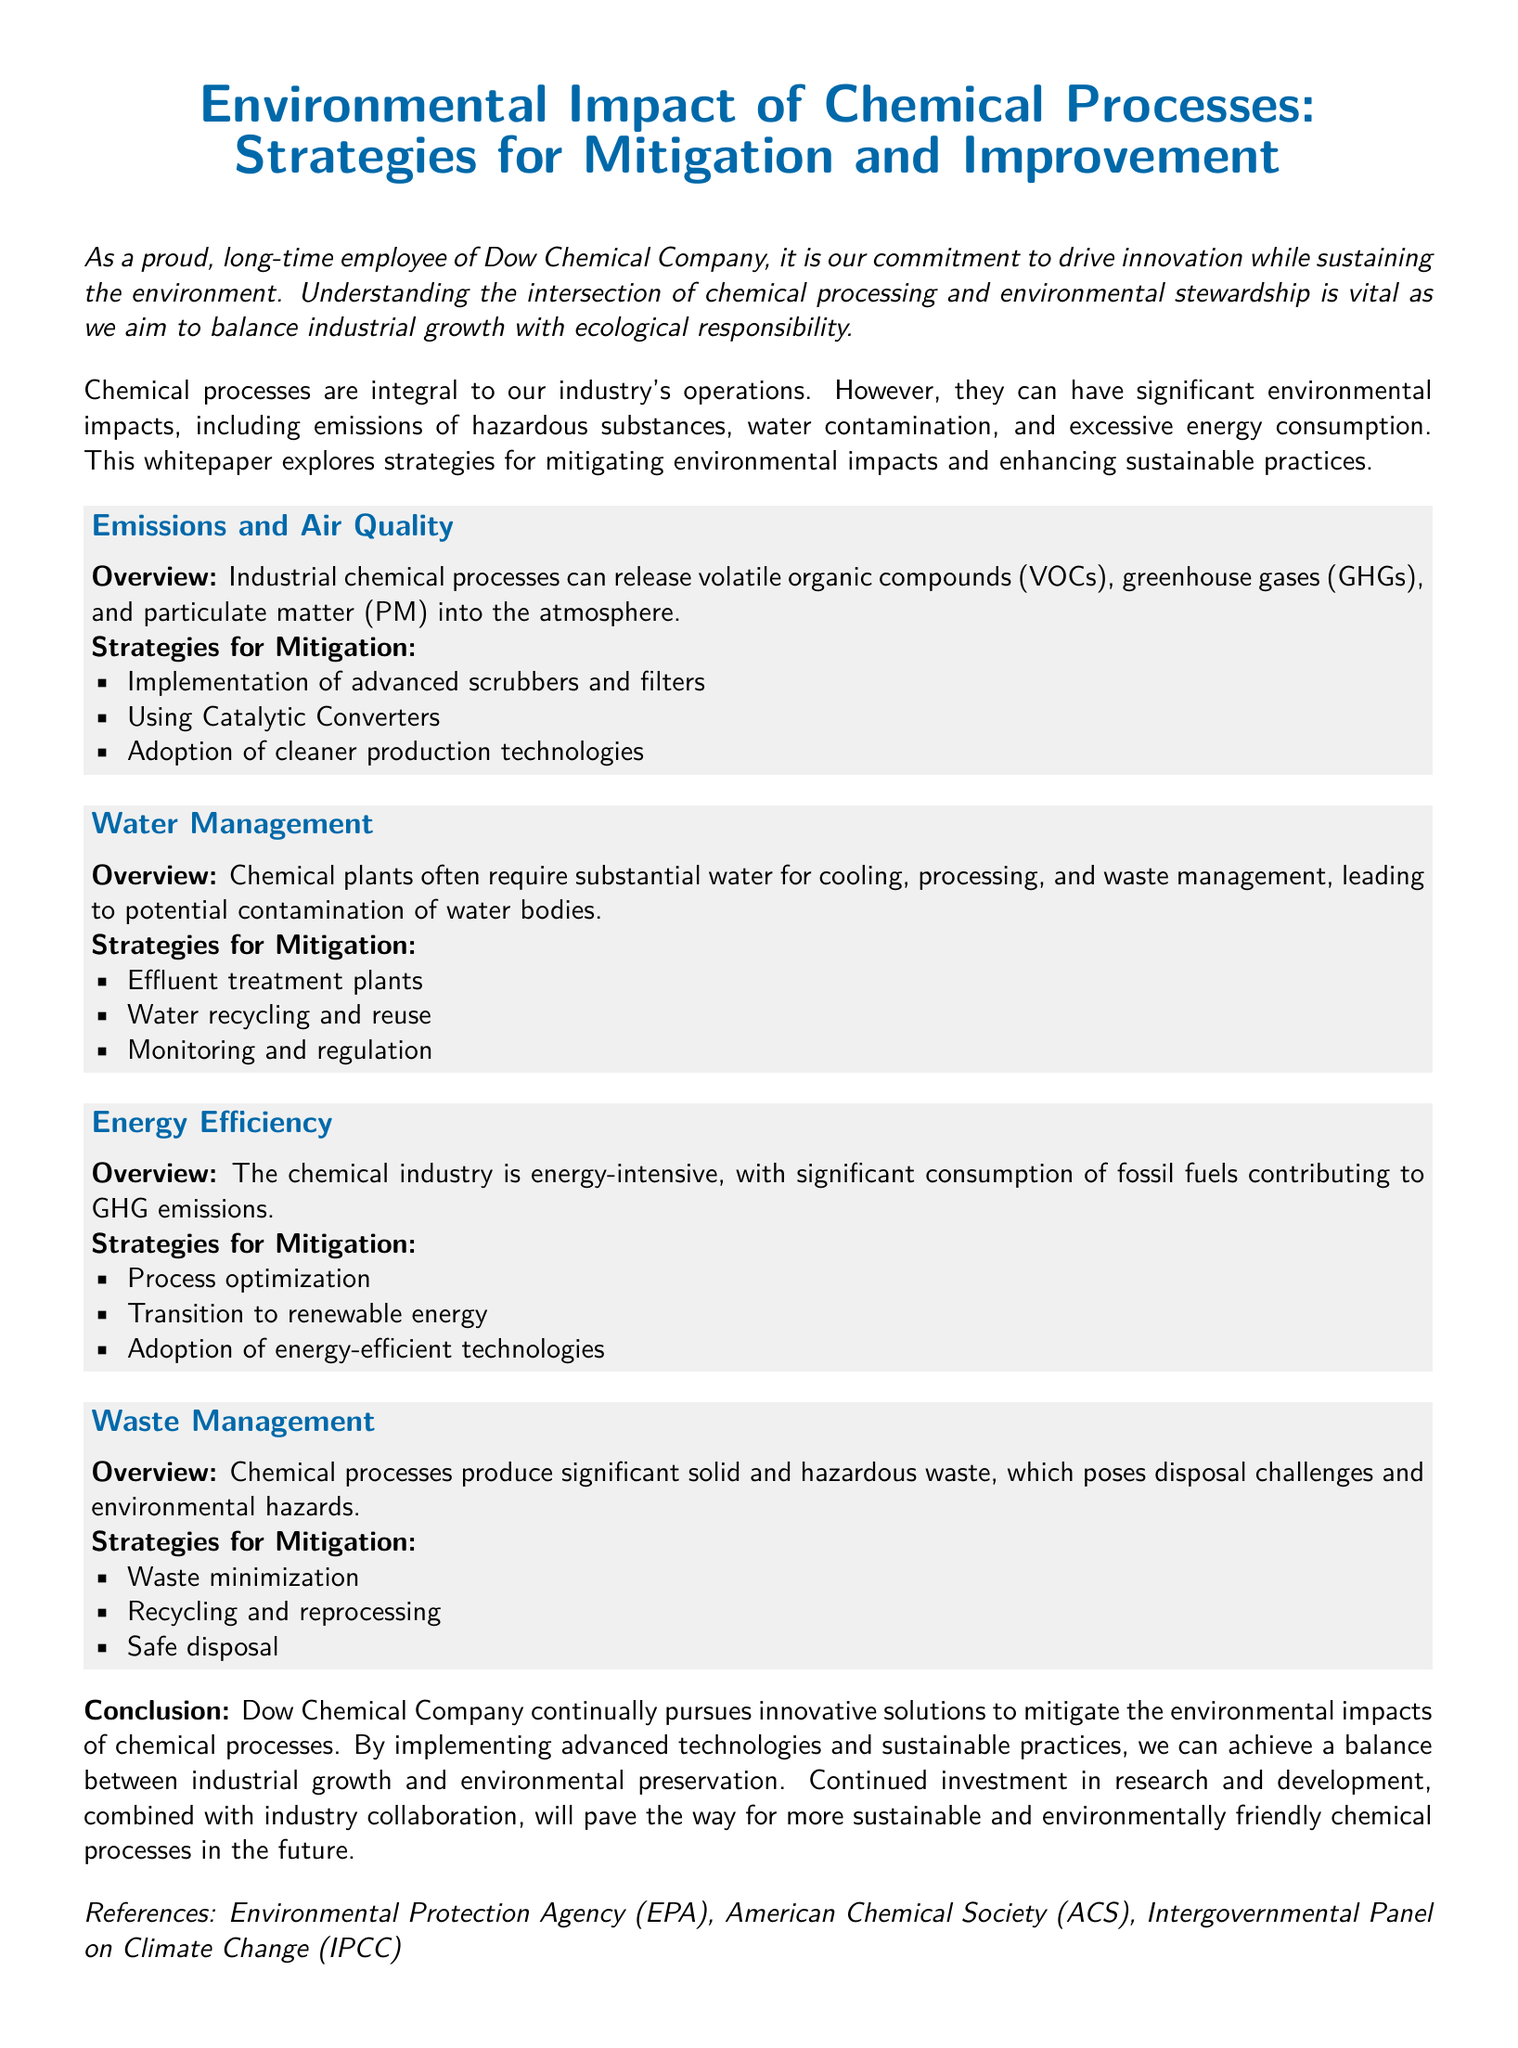What is the main commitment of Dow Chemical Company mentioned in the document? The document states that Dow Chemical Company is committed to driving innovation while sustaining the environment.
Answer: driving innovation while sustaining the environment What are the three types of emissions from chemical processes listed? The document lists volatile organic compounds, greenhouse gases, and particulate matter as emissions from chemical processes.
Answer: volatile organic compounds, greenhouse gases, particulate matter What is one strategy for mitigating emissions? The document lists the implementation of advanced scrubbers and filters as a strategy for mitigating emissions.
Answer: implementation of advanced scrubbers and filters What do chemical plants often require substantial amounts of? The document mentions that chemical plants often require substantial amounts of water for cooling, processing, and waste management.
Answer: water What is a strategy for water management mentioned in the document? One strategy for water management mentioned is water recycling and reuse.
Answer: water recycling and reuse What type of waste poses disposal challenges according to the document? The document states that significant solid and hazardous waste produced by chemical processes poses disposal challenges.
Answer: significant solid and hazardous waste What is a goal mentioned in the conclusion of the document? The goal mentioned is to achieve a balance between industrial growth and environmental preservation.
Answer: balance between industrial growth and environmental preservation What does the document highlight as essential for more sustainable chemical processes? The document highlights continued investment in research and development as essential for more sustainable chemical processes.
Answer: continued investment in research and development Which organizations are referenced in the document? The organizations referenced include the Environmental Protection Agency, American Chemical Society, and Intergovernmental Panel on Climate Change.
Answer: Environmental Protection Agency, American Chemical Society, Intergovernmental Panel on Climate Change 